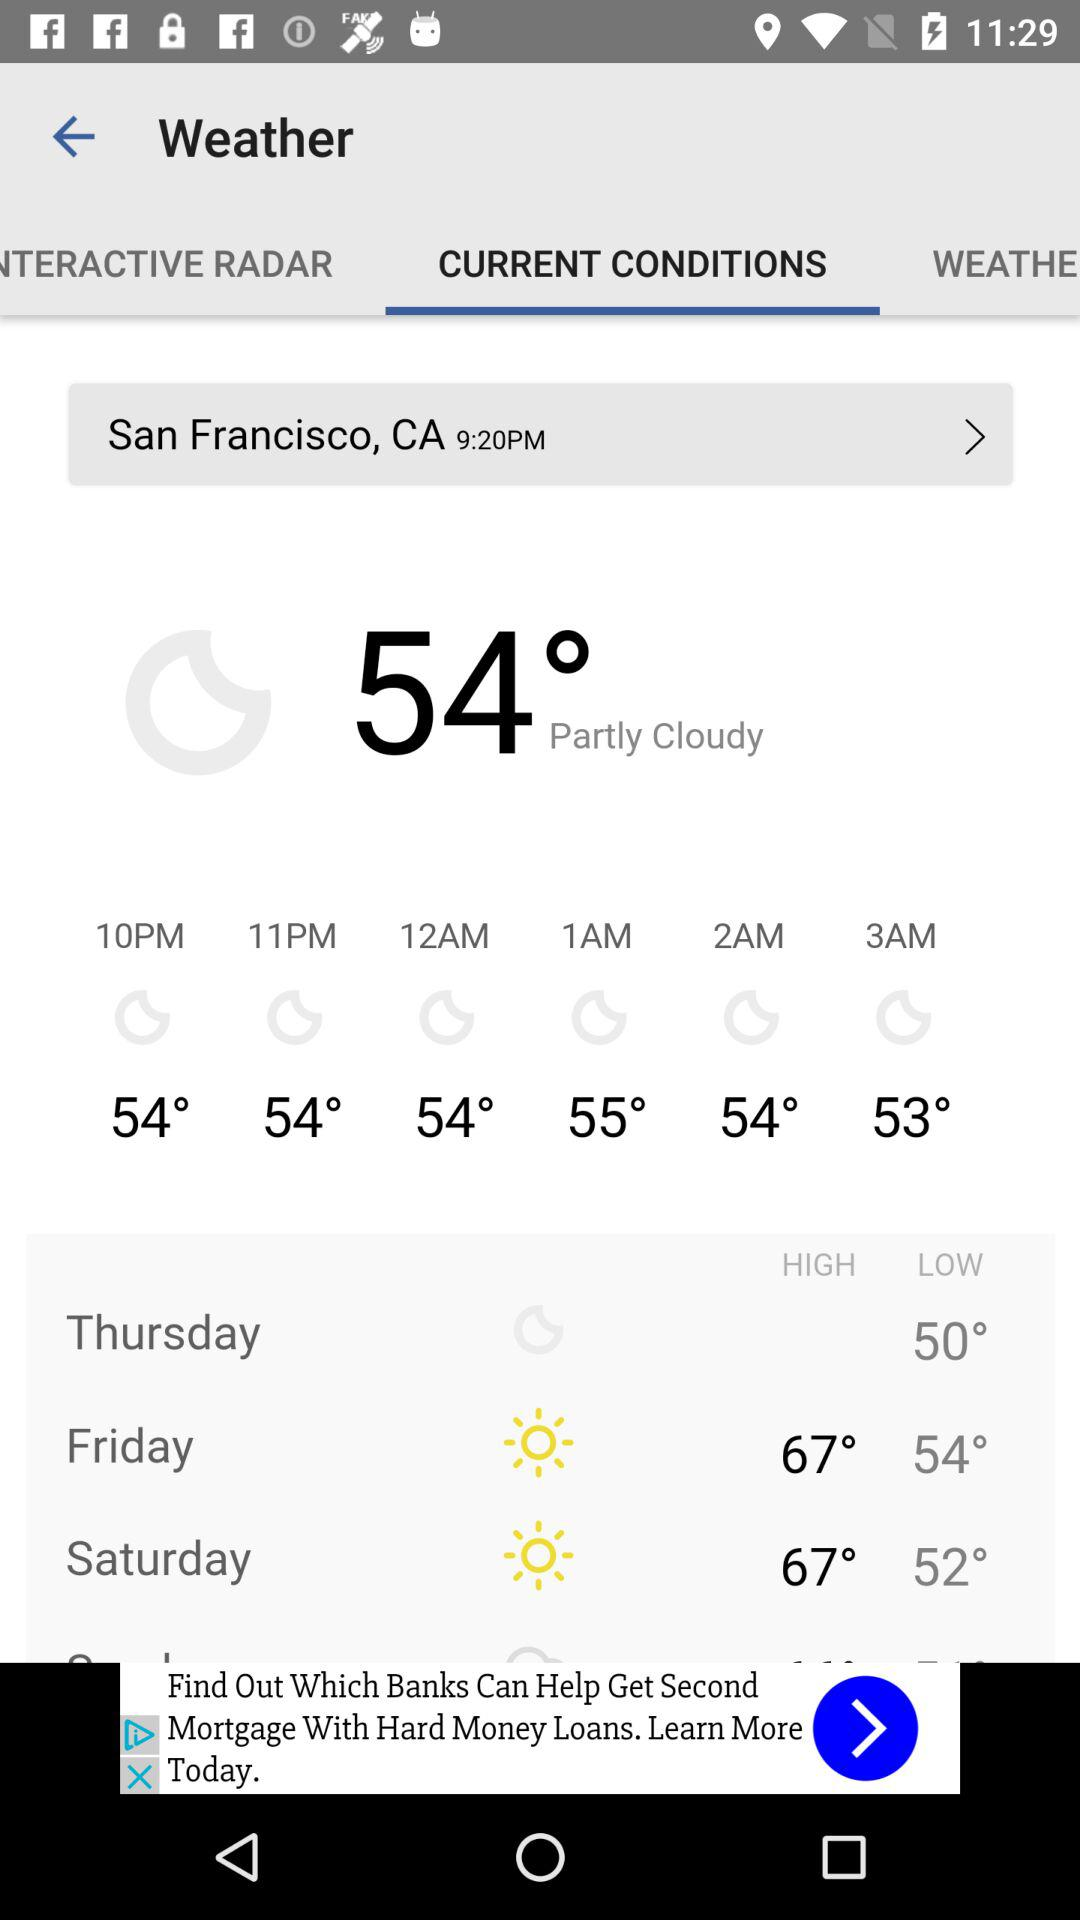What's the time? The time is "9:20PM". 